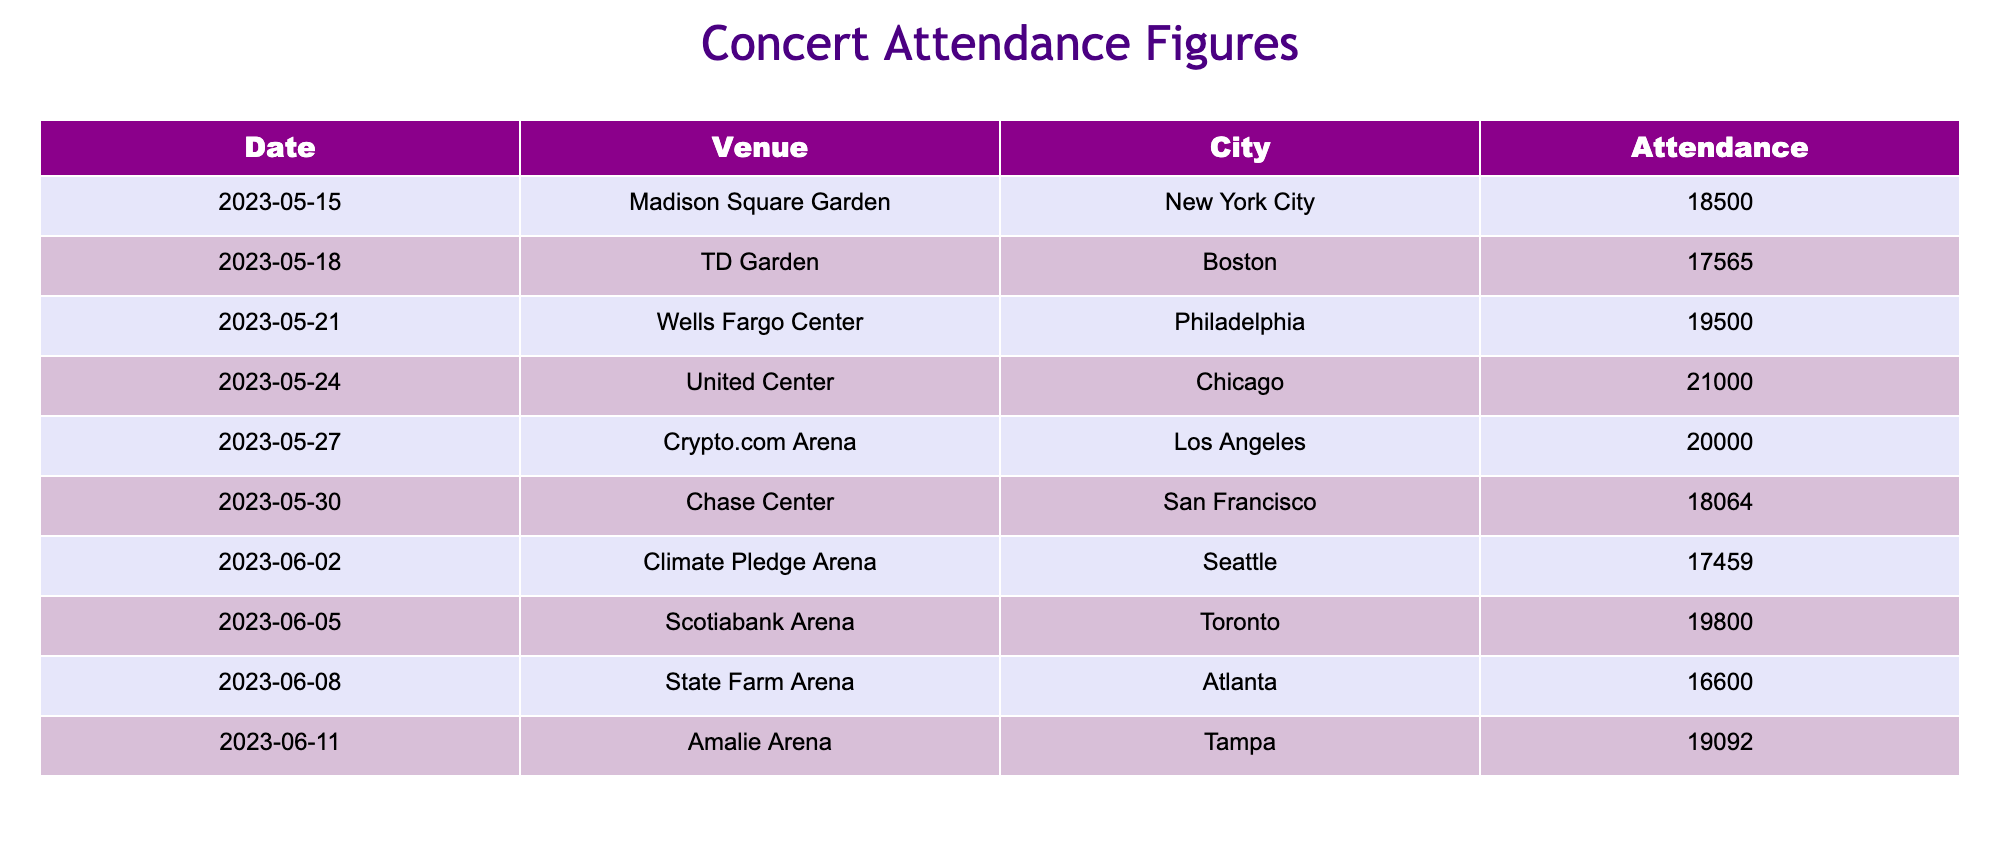What is the highest concert attendance on this tour? The highest attendance can be found by looking at the 'Attendance' column and identifying the maximum value. In this case, the United Center in Chicago had the highest attendance of 21,000.
Answer: 21,000 What is the attendance for the concert held in New York City? From the table, the concert in New York City took place on May 15 at Madison Square Garden, with an attendance of 18,500.
Answer: 18,500 Was the concert in Atlanta the lowest attended event? To check if Atlanta had the lowest attendance, we need to compare its figure (16,600) with all the other attendance numbers in the table. It is confirmed that 16,600 is indeed the lowest value.
Answer: Yes What is the average concert attendance across all listed dates? To find the average, we add all attendance numbers: (18500 + 17565 + 19500 + 21000 + 20000 + 18064 + 17459 + 19800 + 16600 + 19092) = 188770. Then divide this sum by the number of concerts (10): 188770/10 = 18877.0.
Answer: 18877.0 Which city had a concert attendance closest to 19,000? We need to look for attendance numbers that are nearest to 19,000. The closest values are in Philadelphia (19,500) and Tampa (19,092). Tampa's attendance is closer to 19,000.
Answer: Tampa What is the difference in attendance between the Chicago and Boston concerts? The attendance for Chicago is 21,000 and for Boston, it is 17,565. Subtracting these gives: 21,000 - 17,565 = 3,435.
Answer: 3,435 Did the concert in San Francisco have a higher attendance than that in Seattle? Comparing the two figures: San Francisco had an attendance of 18,064 and Seattle had 17,459. Since 18,064 is greater than 17,459, the concert in San Francisco had a higher attendance.
Answer: Yes What are the two cities with the lowest concert attendance figures? From the attendance figures, we can see that Atlanta (16,600) and Seattle (17,459) have the lowest attendances. Thus, the cities with the lowest attendance are Atlanta and Seattle.
Answer: Atlanta and Seattle 